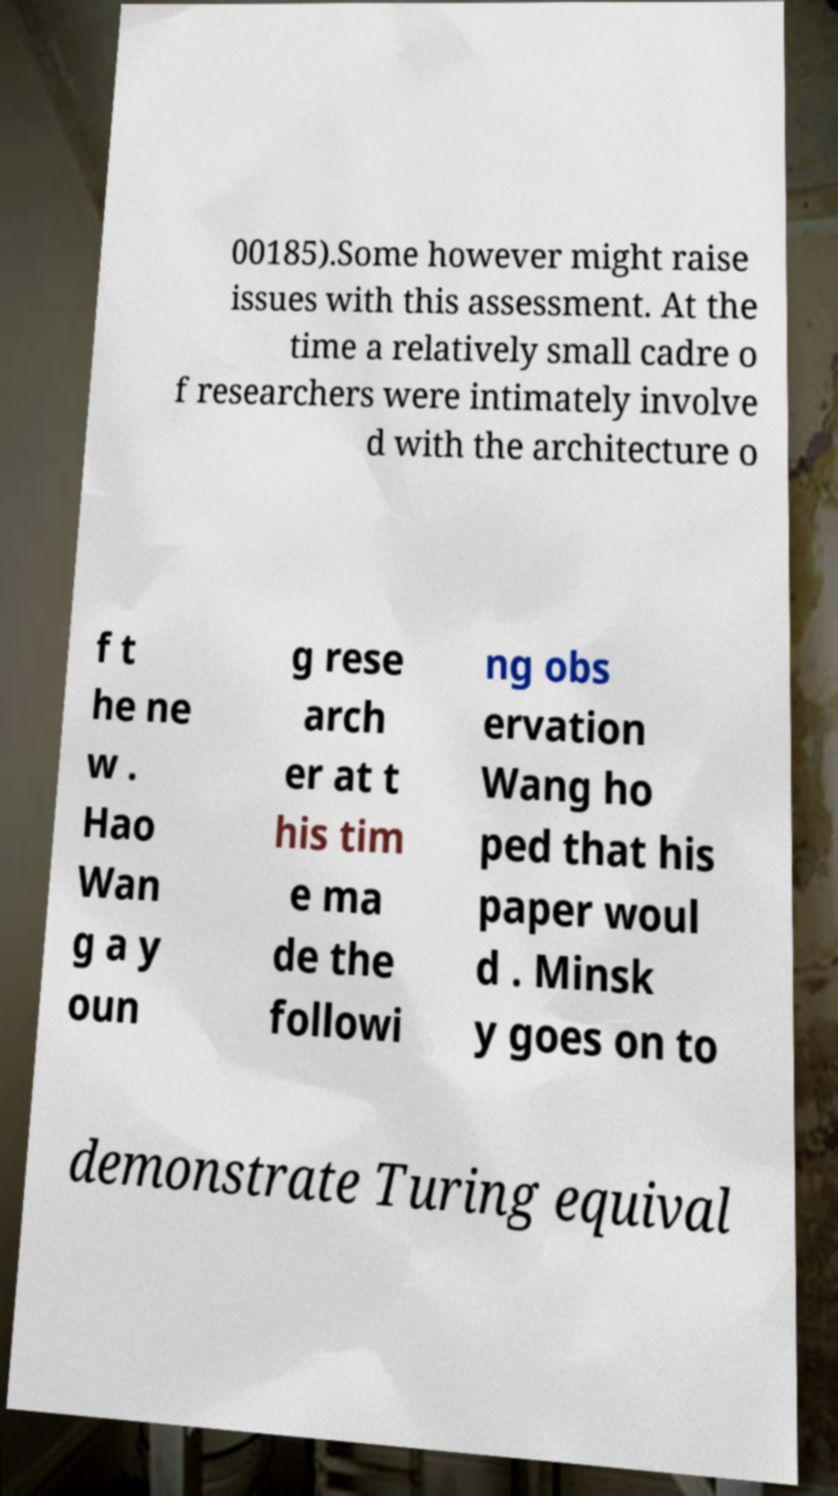Can you read and provide the text displayed in the image?This photo seems to have some interesting text. Can you extract and type it out for me? 00185).Some however might raise issues with this assessment. At the time a relatively small cadre o f researchers were intimately involve d with the architecture o f t he ne w . Hao Wan g a y oun g rese arch er at t his tim e ma de the followi ng obs ervation Wang ho ped that his paper woul d . Minsk y goes on to demonstrate Turing equival 